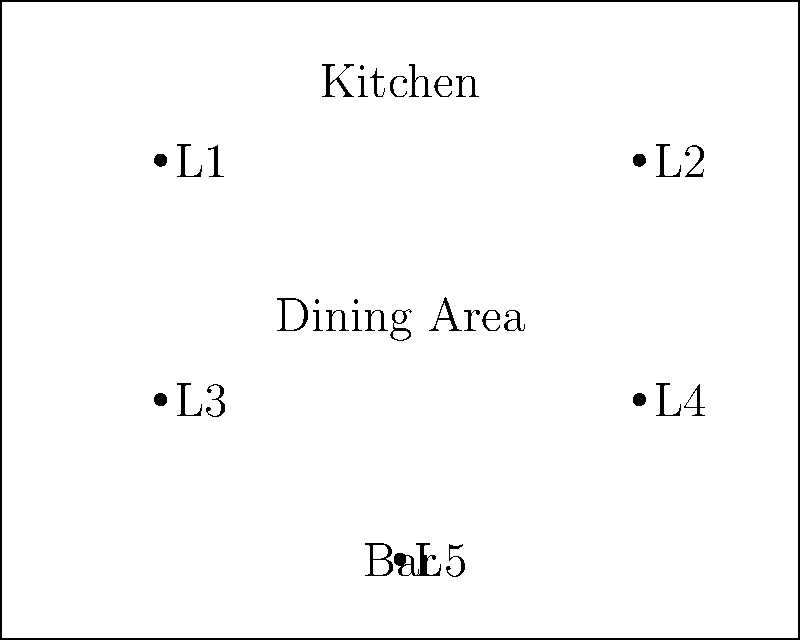In your restaurant, you've installed energy-efficient LED lighting to reduce power consumption. The layout shown above depicts the placement of 5 LED light fixtures (L1 to L5). Each LED fixture consumes 18W and operates for 12 hours daily. If electricity costs $0.15 per kWh, what is the monthly operating cost for this lighting system? To calculate the monthly operating cost, we'll follow these steps:

1. Calculate total power consumption:
   Number of fixtures = 5
   Power per fixture = 18W
   Total power = $5 \times 18\text{W} = 90\text{W}$

2. Convert power to kilowatts:
   $90\text{W} = 0.09\text{kW}$

3. Calculate daily energy consumption:
   Daily operating hours = 12
   Daily energy consumption = $0.09\text{kW} \times 12\text{h} = 1.08\text{kWh}$

4. Calculate monthly energy consumption (assuming 30 days):
   Monthly energy consumption = $1.08\text{kWh} \times 30 = 32.4\text{kWh}$

5. Calculate monthly cost:
   Electricity rate = $0.15 per kWh
   Monthly cost = $32.4\text{kWh} \times \$0.15/\text{kWh} = \$4.86$
Answer: $4.86 